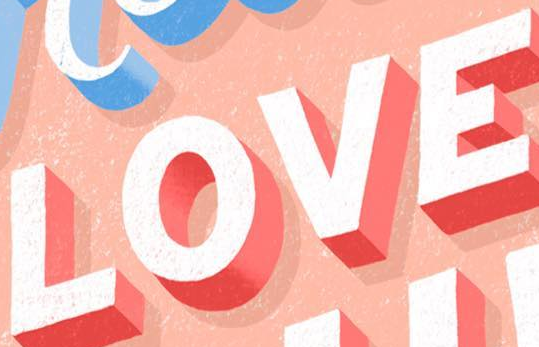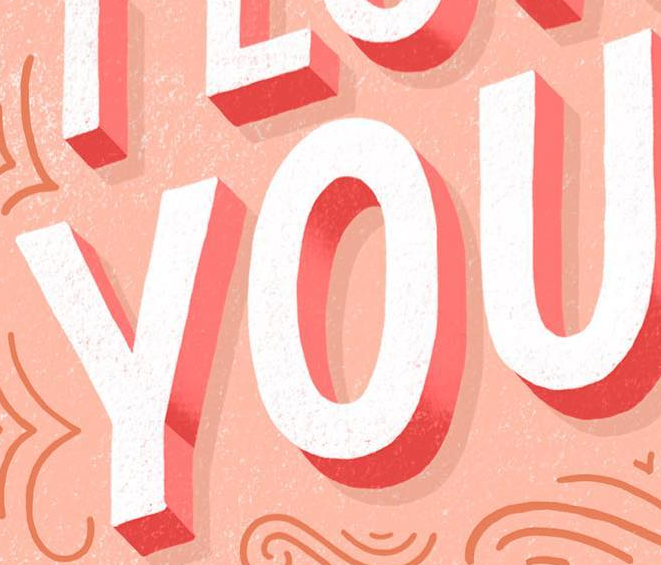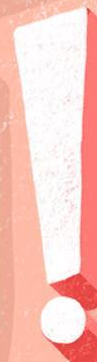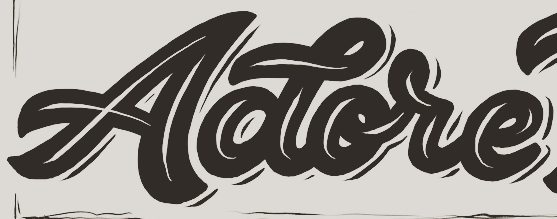Identify the words shown in these images in order, separated by a semicolon. LOVE; YOU; !; Aotore 